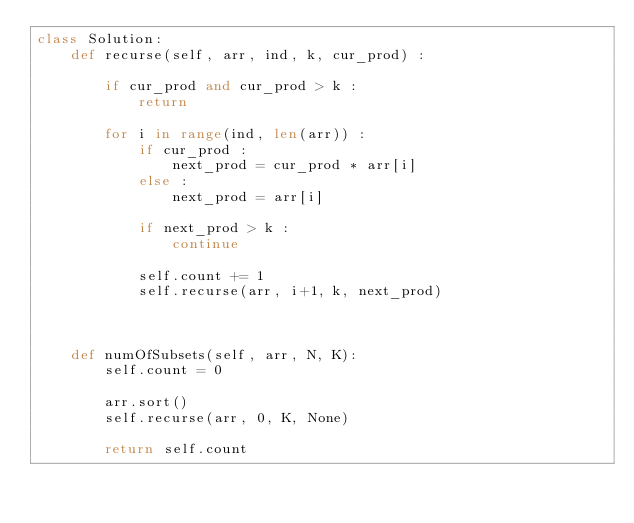<code> <loc_0><loc_0><loc_500><loc_500><_Python_>class Solution:
    def recurse(self, arr, ind, k, cur_prod) :
        
        if cur_prod and cur_prod > k :
            return
        
        for i in range(ind, len(arr)) :
            if cur_prod :
                next_prod = cur_prod * arr[i]
            else :
                next_prod = arr[i]
            
            if next_prod > k :
                continue
            
            self.count += 1
            self.recurse(arr, i+1, k, next_prod)
            
    
    
    def numOfSubsets(self, arr, N, K):
        self.count = 0
        
        arr.sort()
        self.recurse(arr, 0, K, None)

        return self.count
</code> 